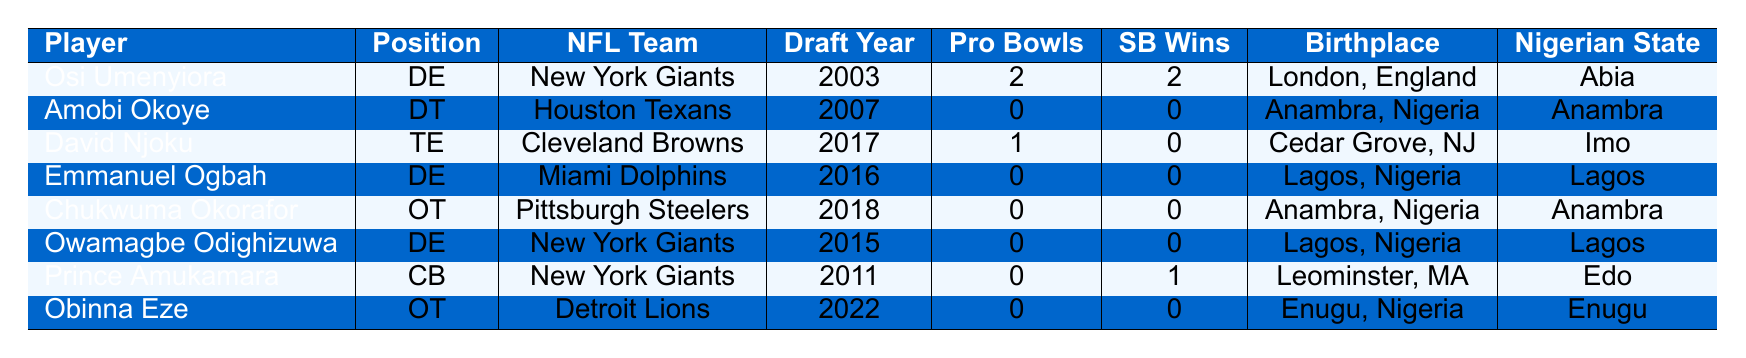What team did Osi Umenyiora play for? Osi Umenyiora is listed under the NFL team 'New York Giants' in the table.
Answer: New York Giants How many Pro Bowls did Amobi Okoye participate in? The table indicates that Amobi Okoye has 0 Pro Bowls listed next to his name.
Answer: 0 Which player has the most Super Bowl wins? Osi Umenyiora and Prince Amukamara are both listed with Super Bowl wins, but Osi Umenyiora has 2, which is the highest number in the table.
Answer: Osi Umenyiora Which Nigerian state does Emmanuel Ogbah represent? The table states that Emmanuel Ogbah's Nigerian state is listed as 'Lagos'.
Answer: Lagos What is the total number of Pro Bowls among all players in the table? The Pro Bowls for each player are summed: 2 (Umenyiora) + 0 (Okoye) + 1 (Njoku) + 0 (Ogbah) + 0 (Okorafor) + 0 (Odighizuwa) + 0 (Amukamara) + 0 (Eze) = 3.
Answer: 3 Is David Njoku a Super Bowl champion? David Njoku has 0 Super Bowl wins listed in the table.
Answer: No How many players come from Anambra state? Amobi Okoye, Chukwuma Okorafor, and David Njoku are the players from Anambra, totaling 3 players from that state.
Answer: 3 Which player has the most recent draft year and what is it? The player with the most recent draft year is Obinna Eze, who was drafted in 2022 as indicated in the table.
Answer: 2022 Are there any players who won Super Bowls but have not attended the Pro Bowl? The table shows Prince Amukamara has 1 Super Bowl win and 0 Pro Bowls, so the statement is true.
Answer: Yes How many defensive ends are listed in the table? The defensive ends listed are Osi Umenyiora, Emmanuel Ogbah, and Owamagbe Odighizuwa, totaling 3 defensive ends.
Answer: 3 